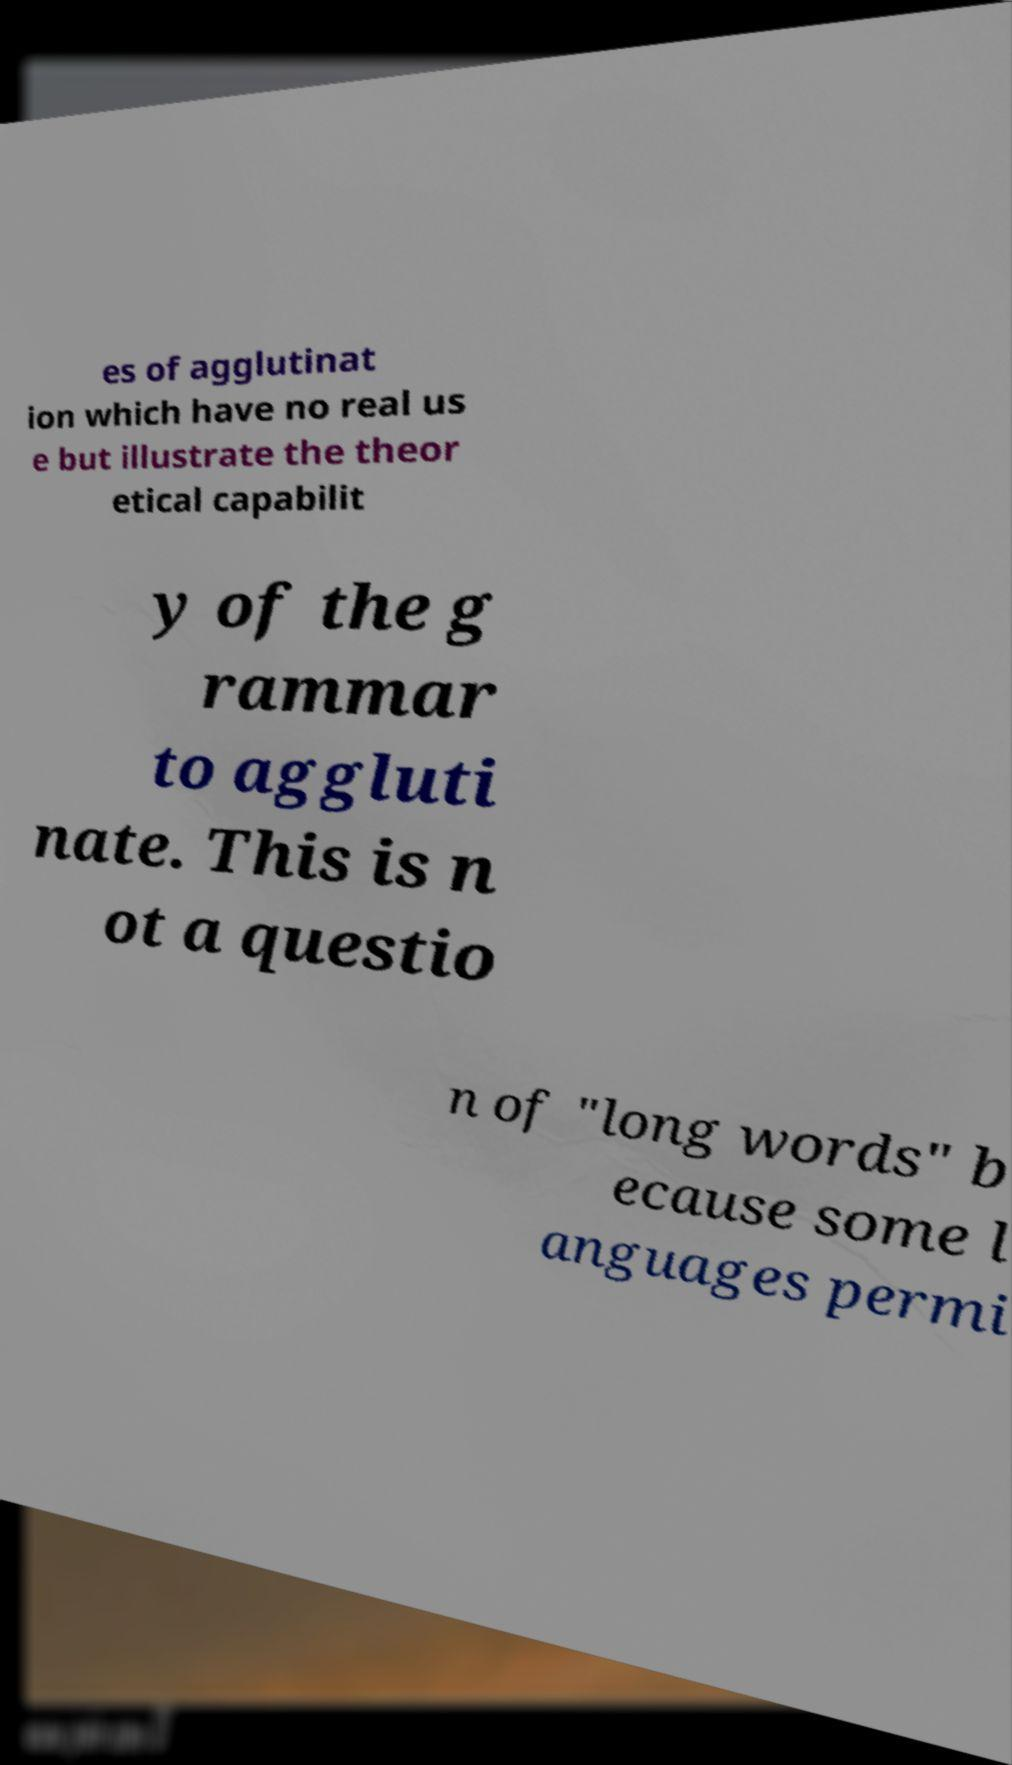There's text embedded in this image that I need extracted. Can you transcribe it verbatim? es of agglutinat ion which have no real us e but illustrate the theor etical capabilit y of the g rammar to aggluti nate. This is n ot a questio n of "long words" b ecause some l anguages permi 